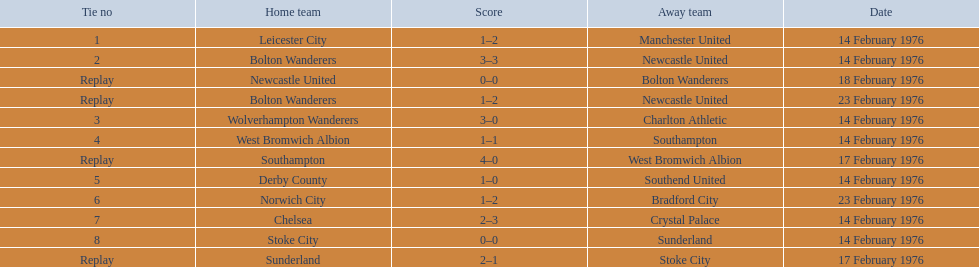How many games were replays? 4. 